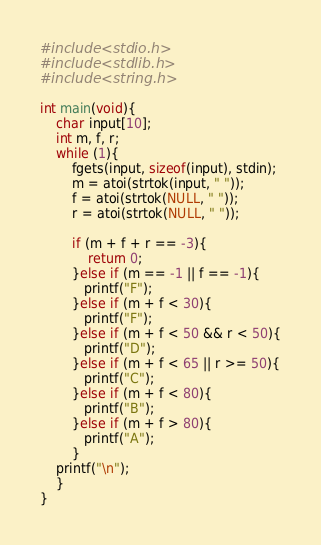<code> <loc_0><loc_0><loc_500><loc_500><_C_>#include <stdio.h>
#include <stdlib.h>
#include <string.h>

int main(void){
    char input[10];
    int m, f, r;
    while (1){
        fgets(input, sizeof(input), stdin);
        m = atoi(strtok(input, " "));
        f = atoi(strtok(NULL, " "));
        r = atoi(strtok(NULL, " "));

        if (m + f + r == -3){
            return 0;
        }else if (m == -1 || f == -1){
           printf("F");
        }else if (m + f < 30){
           printf("F");
        }else if (m + f < 50 && r < 50){
           printf("D");
        }else if (m + f < 65 || r >= 50){
           printf("C");
        }else if (m + f < 80){
           printf("B");
        }else if (m + f > 80){
           printf("A");
        }
    printf("\n");
    }
}</code> 